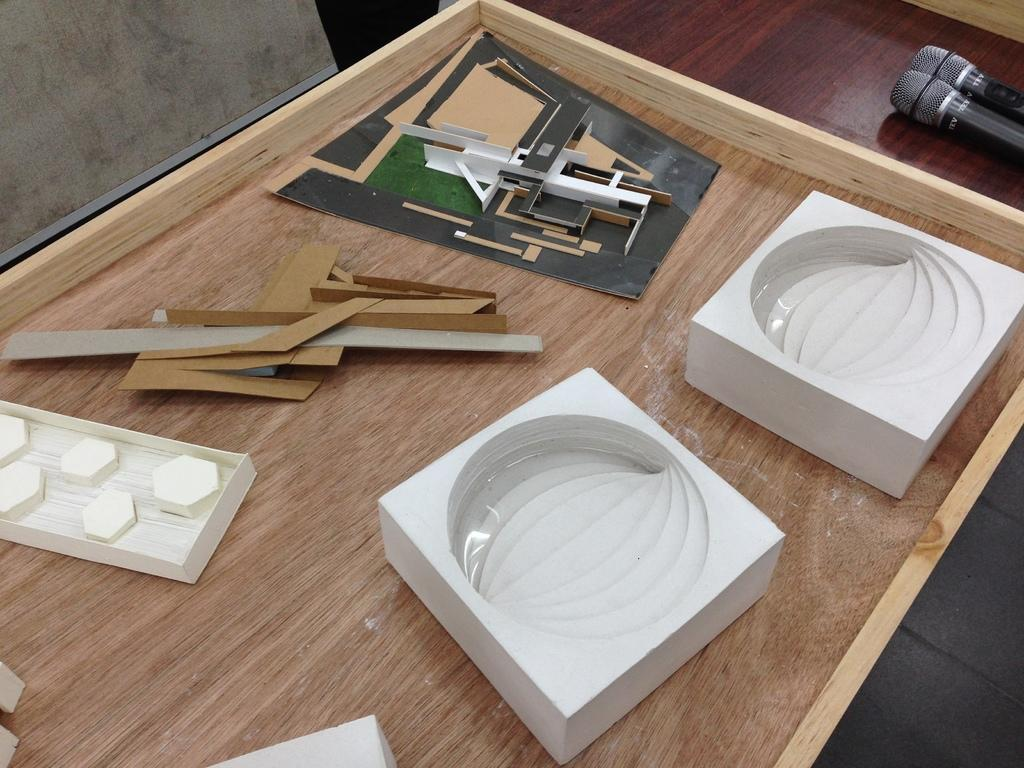What is the main object in the image? There is a table in the image. What is placed on the table? There are wooden pieces of different shapes on the table. Are there any other objects visible in the image? Yes, there are two microphones (mics) in the image. What type of education is being provided at the shop in the image? There is no shop or education present in the image; it features a table with wooden pieces and microphones. What is the profit margin for the items in the image? There is no indication of a shop or profit margin in the image; it simply shows a table with wooden pieces and microphones. 